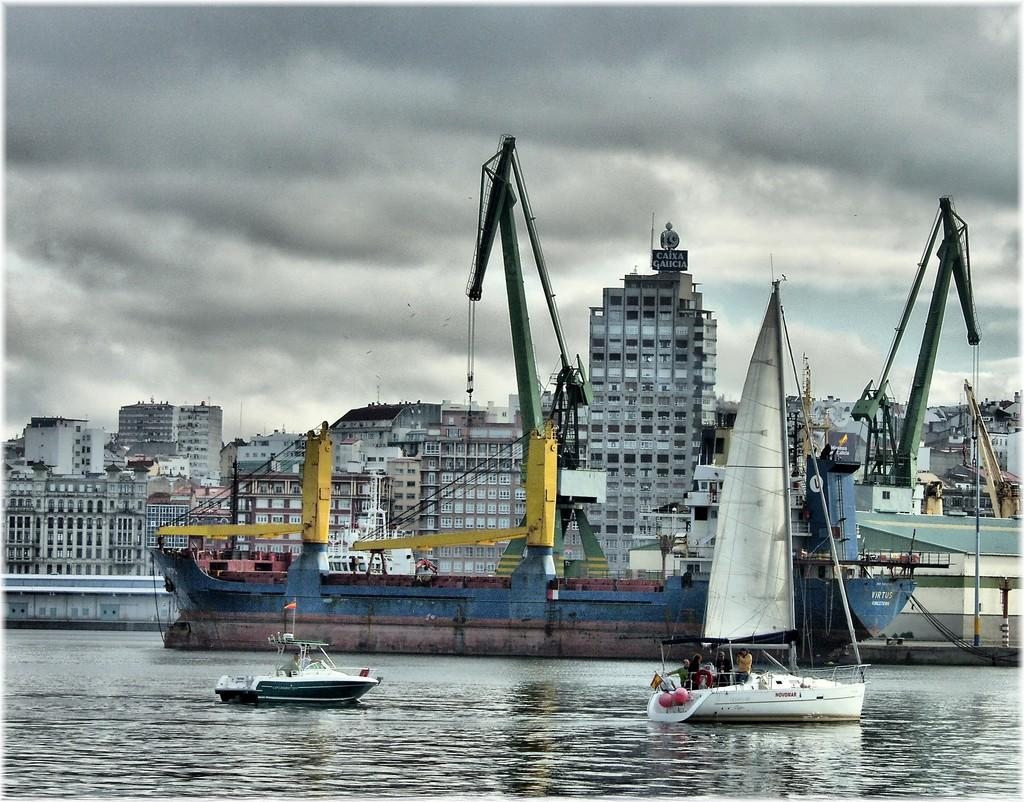What is the main subject in the image? There is a ship in the image. Are there any other watercraft visible in the image? Yes, there are two boats sailing in the image. Where are the boats sailing? The boats are sailing in the water. What can be seen in the background of the image? There are buildings in the background of the image. How would you describe the sky in the image? The sky is cloudy at the top of the image. What type of show is being performed on the ship in the image? There is no indication of a show being performed on the ship in the image. Can you tell me how many people are skating on the boats in the image? There are no people skating on the boats in the image; they are sailing in the water. 